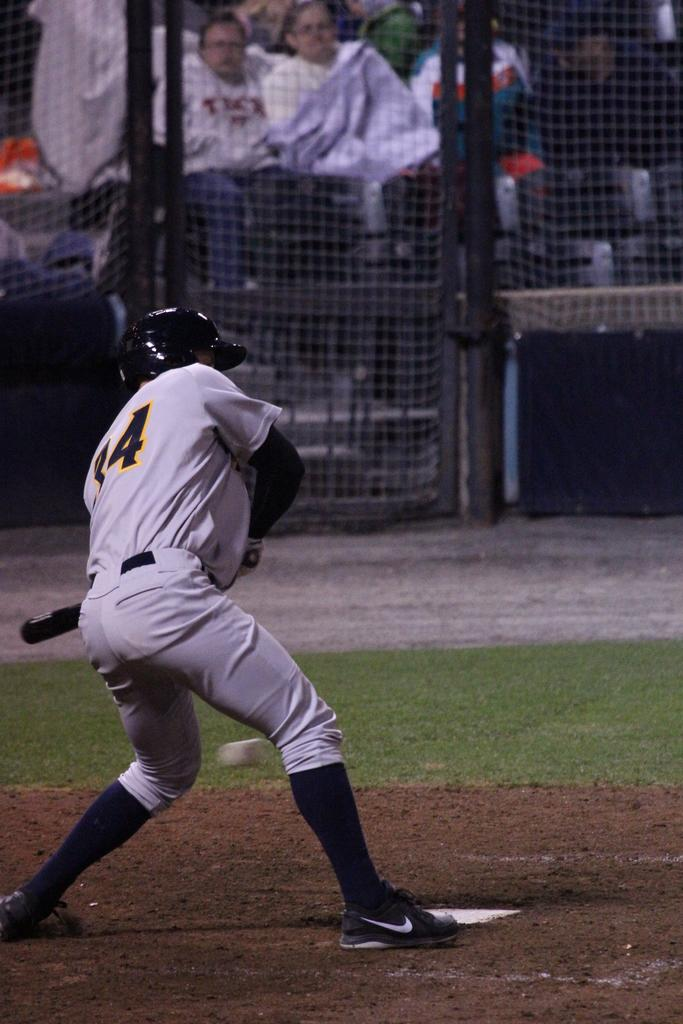<image>
Give a short and clear explanation of the subsequent image. a baseball player wearing the number '34' uniform 